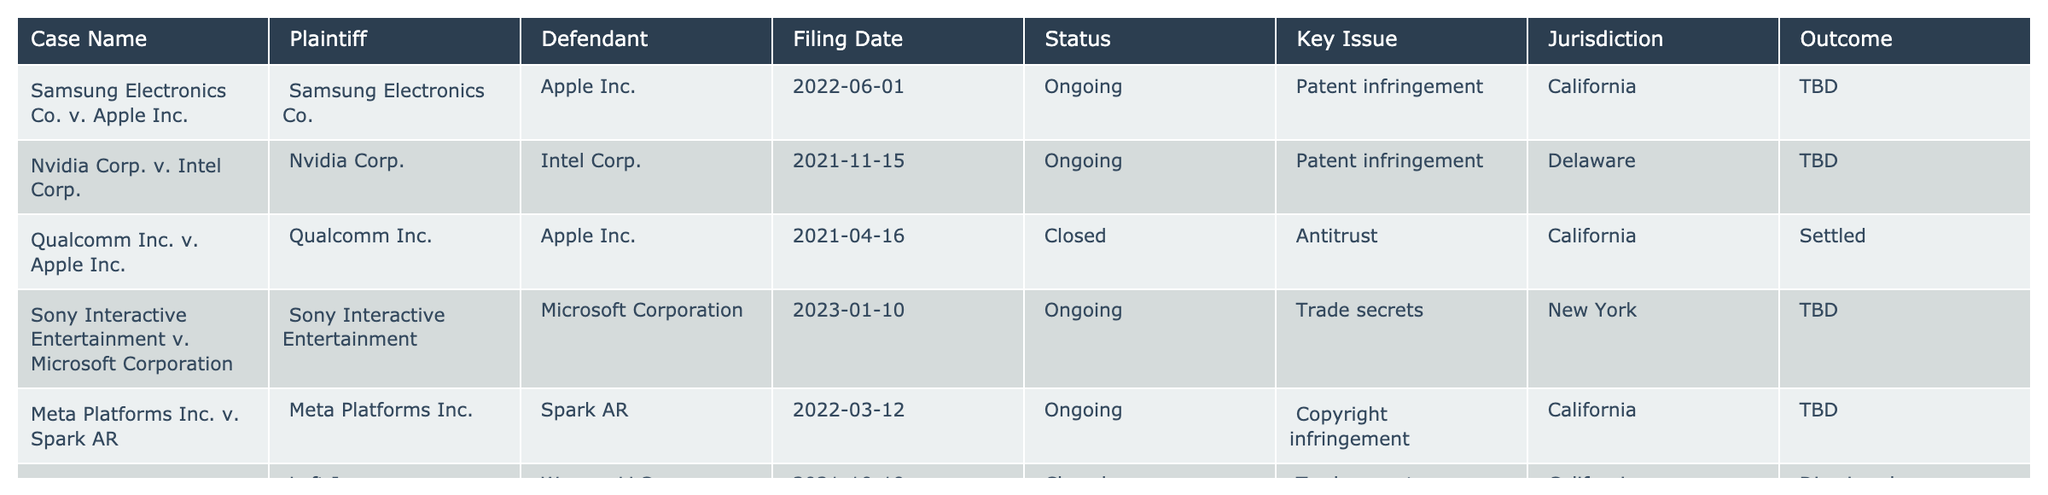What is the key issue in the case involving Samsung Electronics and Apple Inc.? The table lists "Patent infringement" as the key issue for the case Samsung Electronics Co. v. Apple Inc.
Answer: Patent infringement In which jurisdiction is the Nvidia Corp. v. Intel Corp. case filed? The table indicates that the case Nvidia Corp. v. Intel Corp. is filed in Delaware.
Answer: Delaware How many cases are currently ongoing according to the table? The table shows four cases with an "Ongoing" status: Samsung v. Apple, Nvidia v. Intel, Sony v. Microsoft, and Meta v. Spark AR, totaling to four ongoing cases.
Answer: Four Which case has been dismissed? According to the table, the case Lyft Inc. v. Waymo LLC has been dismissed.
Answer: Lyft Inc. v. Waymo LLC Is there any case that has been settled? The table indicates that the Qualcomm Inc. v. Apple Inc. case has a status of "Settled," therefore there is at least one case that has been settled.
Answer: Yes Which case involves trade secrets and is currently ongoing? Referring to the table, the case Sony Interactive Entertainment v. Microsoft Corporation involves trade secrets and is marked as ongoing.
Answer: Sony Interactive Entertainment v. Microsoft Corporation What percentage of the listed cases have been closed? There are 2 out of 6 cases closed; to calculate the percentage: (2 closed / 6 total) x 100 = 33.33%.
Answer: 33.33% Are there any patent infringement cases currently ongoing? The table shows that there are two cases related to patent infringement that are ongoing: Samsung v. Apple and Nvidia v. Intel.
Answer: Yes What is the outcome of the case between Qualcomm Inc. and Apple Inc.? According to the table, the outcome of the Qualcomm Inc. v. Apple Inc. case is designated as "Settled."
Answer: Settled How many cases are filed in California, and what are their key issues? The table lists three cases in California: Samsung v. Apple (Patent infringement), Qualcomm v. Apple (Antitrust), and Meta v. Spark AR (Copyright infringement). So, there are three cases.
Answer: Three cases: Patent infringement, Antitrust, Copyright infringement Which case has the most recent filing date? The most recent filing date is January 10, 2023, for the case Sony Interactive Entertainment v. Microsoft Corporation.
Answer: Sony Interactive Entertainment v. Microsoft Corporation Is there a case in New York, and what is its status? Yes, the case Sony Interactive Entertainment v. Microsoft Corporation is filed in New York and is currently ongoing.
Answer: Yes, ongoing 